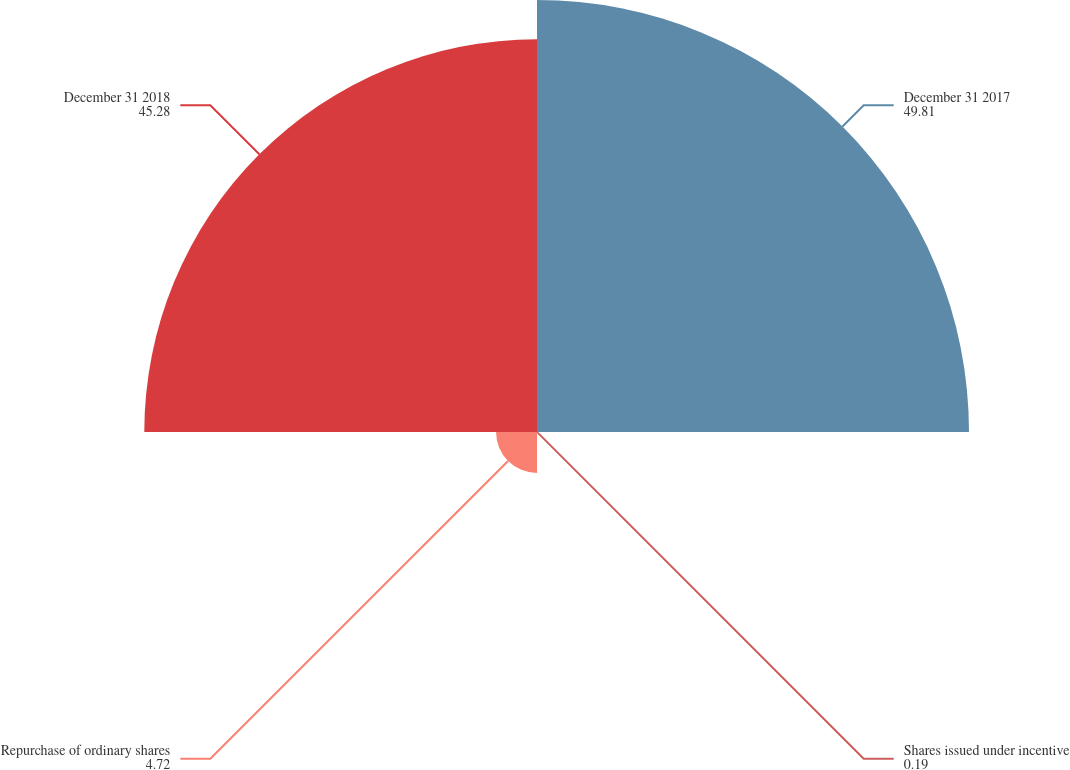<chart> <loc_0><loc_0><loc_500><loc_500><pie_chart><fcel>December 31 2017<fcel>Shares issued under incentive<fcel>Repurchase of ordinary shares<fcel>December 31 2018<nl><fcel>49.81%<fcel>0.19%<fcel>4.72%<fcel>45.28%<nl></chart> 